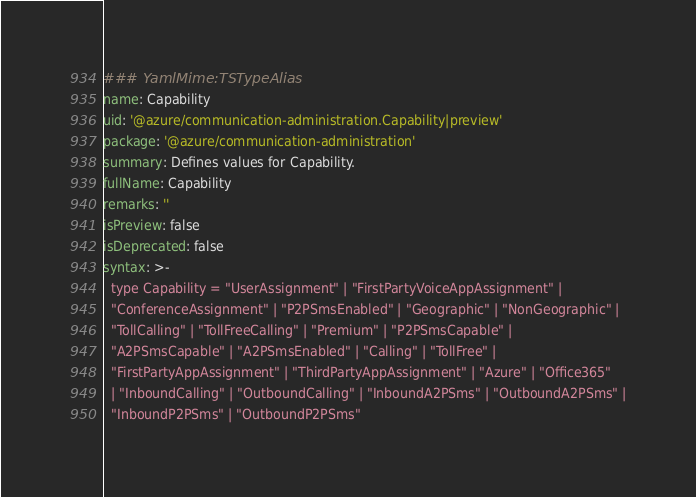<code> <loc_0><loc_0><loc_500><loc_500><_YAML_>### YamlMime:TSTypeAlias
name: Capability
uid: '@azure/communication-administration.Capability|preview'
package: '@azure/communication-administration'
summary: Defines values for Capability.
fullName: Capability
remarks: ''
isPreview: false
isDeprecated: false
syntax: >-
  type Capability = "UserAssignment" | "FirstPartyVoiceAppAssignment" |
  "ConferenceAssignment" | "P2PSmsEnabled" | "Geographic" | "NonGeographic" |
  "TollCalling" | "TollFreeCalling" | "Premium" | "P2PSmsCapable" |
  "A2PSmsCapable" | "A2PSmsEnabled" | "Calling" | "TollFree" |
  "FirstPartyAppAssignment" | "ThirdPartyAppAssignment" | "Azure" | "Office365"
  | "InboundCalling" | "OutboundCalling" | "InboundA2PSms" | "OutboundA2PSms" |
  "InboundP2PSms" | "OutboundP2PSms"
</code> 